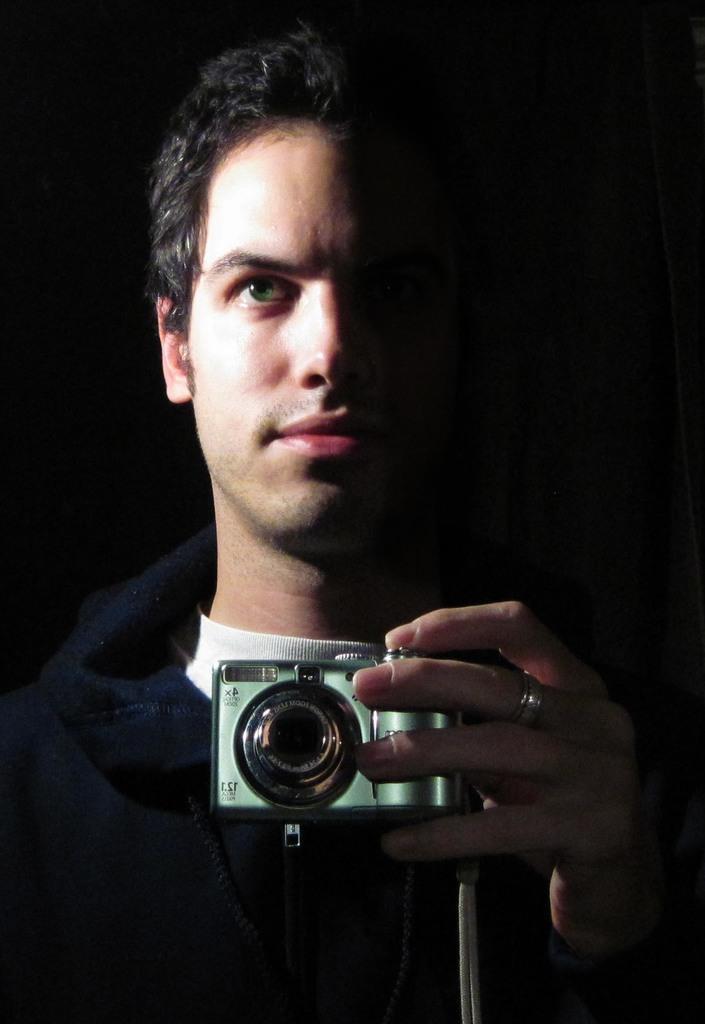Describe this image in one or two sentences. a person is standing , holding a camera in his hand. he is wearing a blue and white t shirt and a ring is present in his middle finger. 